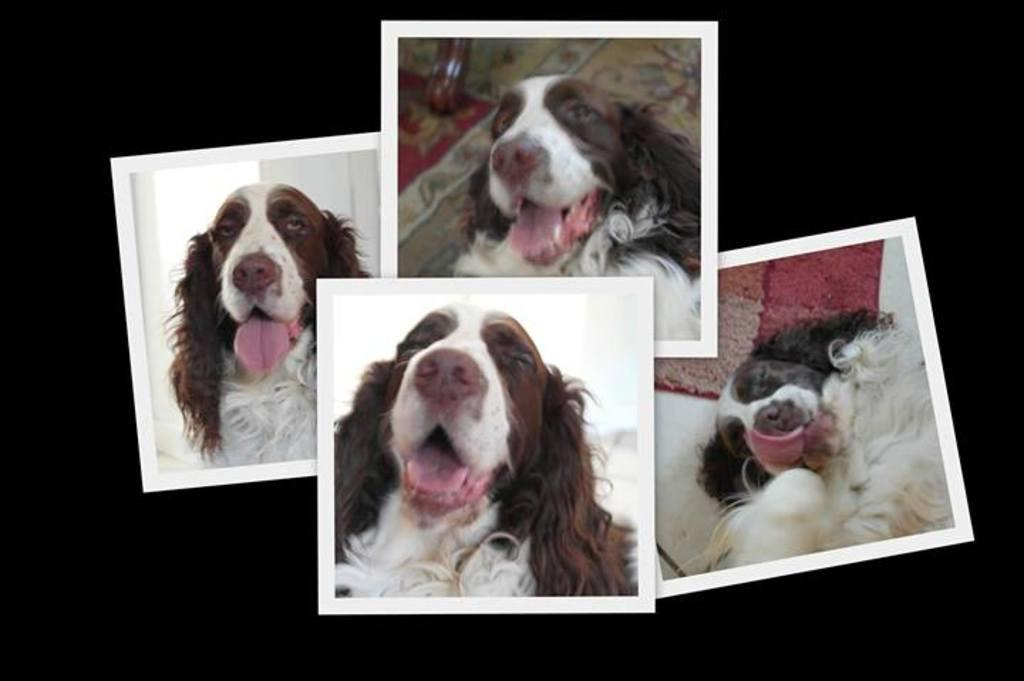What is the main subject of the four photos in the image? The main subject of the four photos is a dog. How are the photos of the dog different from each other? The photos show the dog from different angles. What can be seen behind the dog in the photos? There is a dark background in the image. What type of lumber is being used to build the doghouse in the image? There is no doghouse present in the image, so it is not possible to determine what type of lumber is being used. 